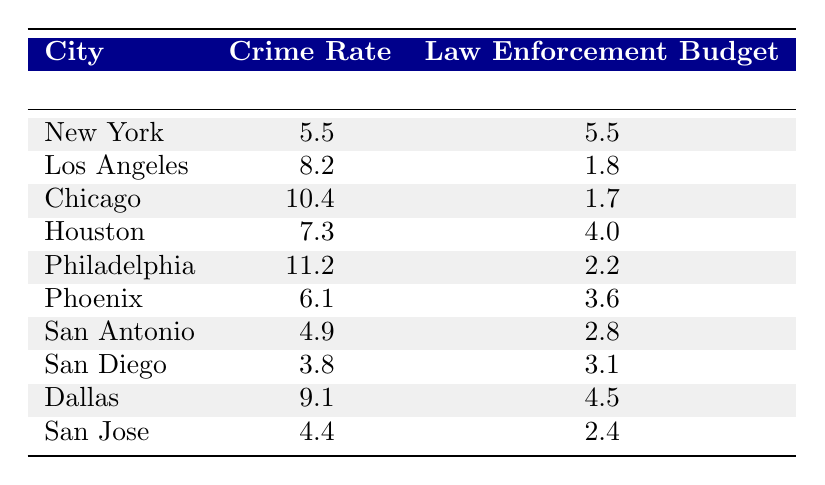What is the crime rate in Philadelphia? From the table, under the row for Philadelphia, the crime rate is listed as 11.2 per 1000.
Answer: 11.2 Which city has the highest law enforcement budget? By examining the law enforcement budget column, New York has the highest budget listed at 5.5 million.
Answer: New York Is the crime rate in San Diego lower than in Houston? The crime rate for San Diego is 3.8 per 1000, while Houston's is 7.3 per 1000. Since 3.8 is less than 7.3, the statement is true.
Answer: Yes Calculate the average law enforcement budget for all cities listed in the table. To find the average, add all the budgets: 5.5 + 1.8 + 1.7 + 4.0 + 2.2 + 3.6 + 2.8 + 3.1 + 4.5 + 2.4 = 27.6 million. There are 10 cities, so 27.6 / 10 = 2.76 million.
Answer: 2.76 Does a higher law enforcement budget correlate with lower crime rates in the cities listed? A review of the table shows that New York has a higher budget and a lower crime rate, while Los Angeles has a lower budget and a higher crime rate, suggesting there might not be a consistent correlation.
Answer: No 